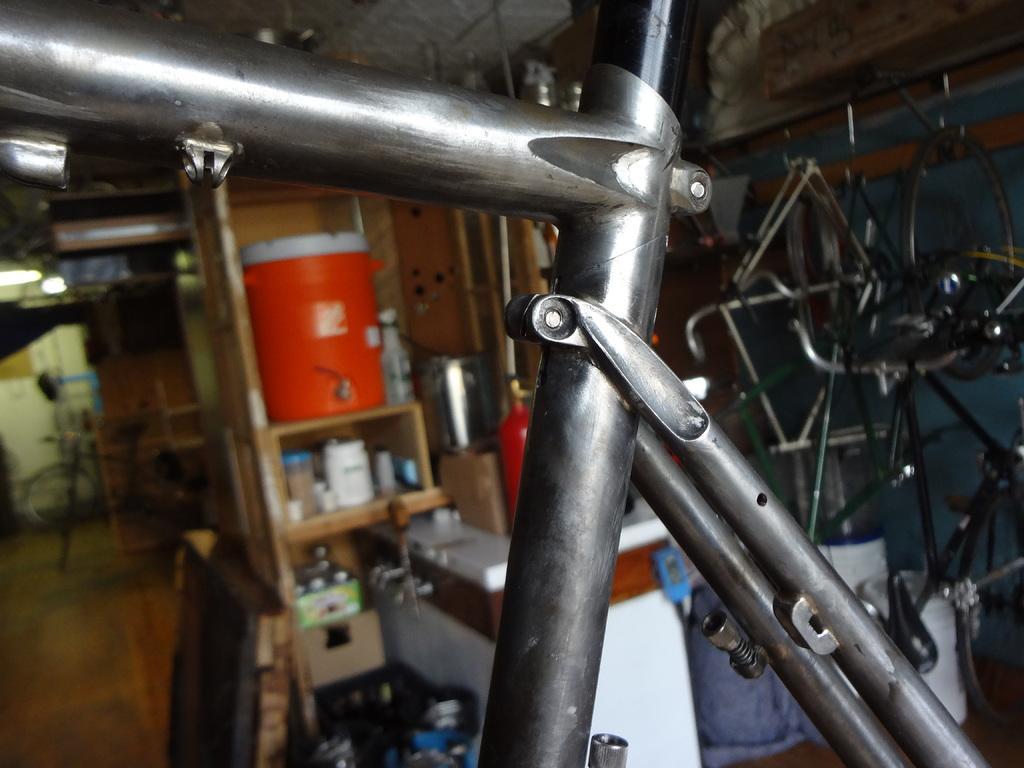How would you summarize this image in a sentence or two? In this image I can see a wooden shelf which has some objects on it. On the right side I can see some metal objects. I can also see some objects on the floor. The background of the image is blurred. 